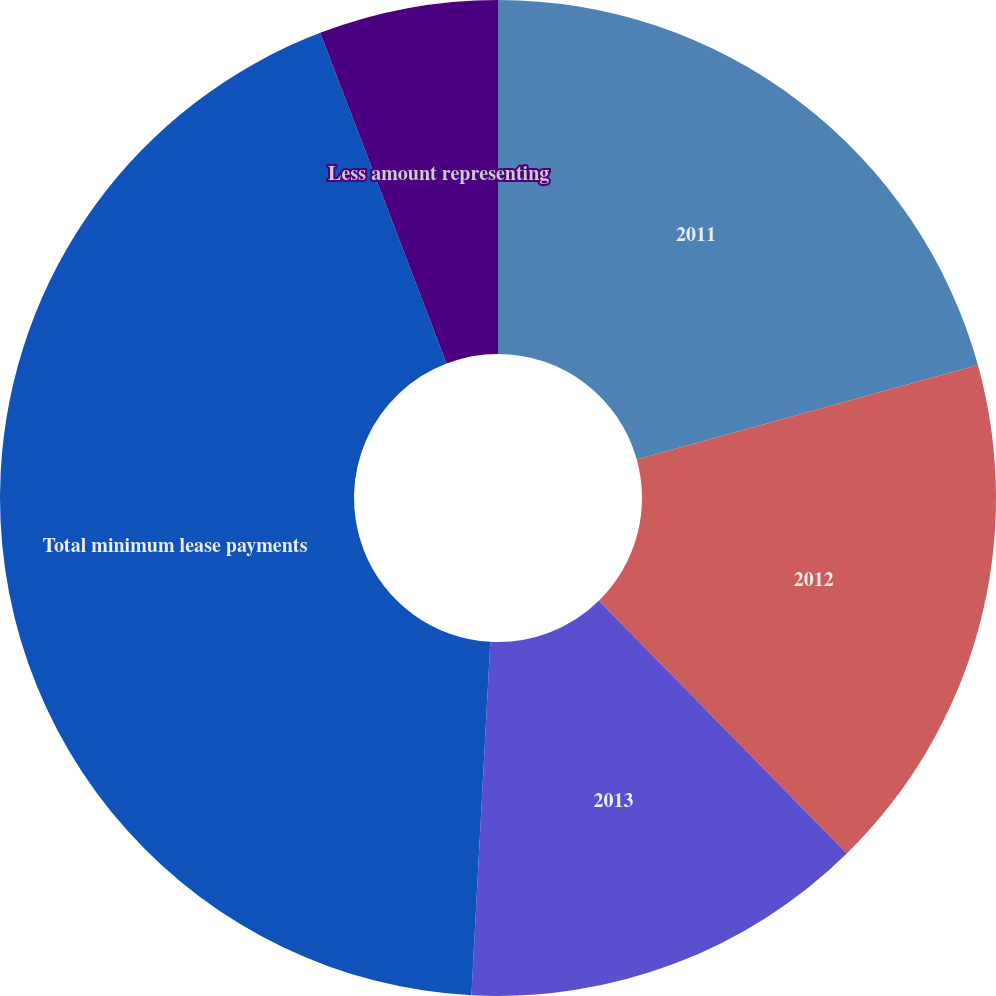Convert chart. <chart><loc_0><loc_0><loc_500><loc_500><pie_chart><fcel>2011<fcel>2012<fcel>2013<fcel>Total minimum lease payments<fcel>Less amount representing<nl><fcel>20.7%<fcel>16.95%<fcel>13.2%<fcel>43.34%<fcel>5.81%<nl></chart> 